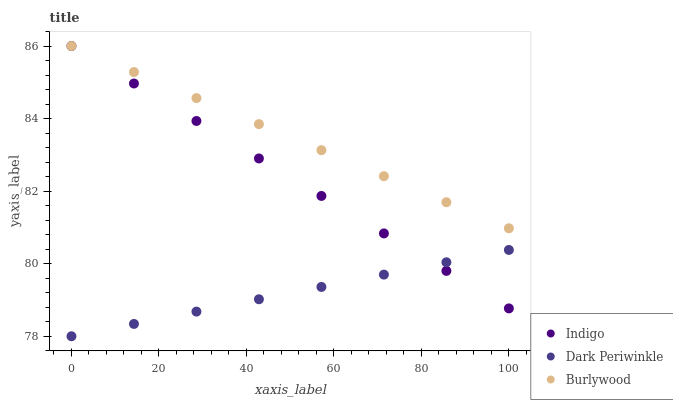Does Dark Periwinkle have the minimum area under the curve?
Answer yes or no. Yes. Does Burlywood have the maximum area under the curve?
Answer yes or no. Yes. Does Indigo have the minimum area under the curve?
Answer yes or no. No. Does Indigo have the maximum area under the curve?
Answer yes or no. No. Is Dark Periwinkle the smoothest?
Answer yes or no. Yes. Is Burlywood the roughest?
Answer yes or no. Yes. Is Indigo the smoothest?
Answer yes or no. No. Is Indigo the roughest?
Answer yes or no. No. Does Dark Periwinkle have the lowest value?
Answer yes or no. Yes. Does Indigo have the lowest value?
Answer yes or no. No. Does Indigo have the highest value?
Answer yes or no. Yes. Does Dark Periwinkle have the highest value?
Answer yes or no. No. Is Dark Periwinkle less than Burlywood?
Answer yes or no. Yes. Is Burlywood greater than Dark Periwinkle?
Answer yes or no. Yes. Does Burlywood intersect Indigo?
Answer yes or no. Yes. Is Burlywood less than Indigo?
Answer yes or no. No. Is Burlywood greater than Indigo?
Answer yes or no. No. Does Dark Periwinkle intersect Burlywood?
Answer yes or no. No. 